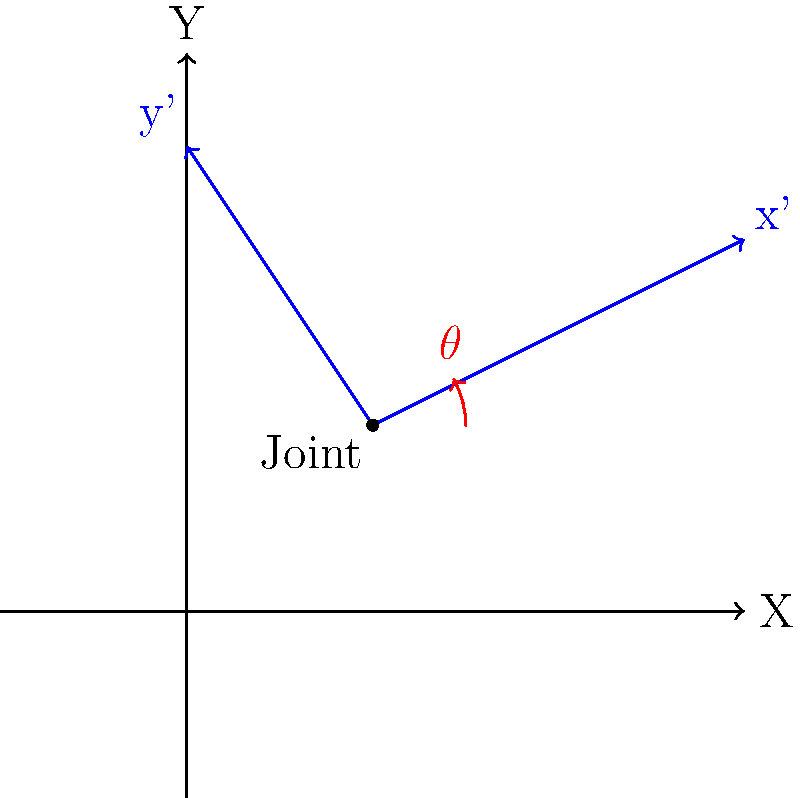In a biomechanical model of the human arm, a joint angle $\theta$ is measured as 30° in the local coordinate system (x', y'). The local coordinate system is rotated 45° counterclockwise relative to the global coordinate system (X, Y). What is the joint angle $\theta_{global}$ in the global coordinate system? To solve this problem, we need to follow these steps:

1) Understand the given information:
   - Local joint angle $\theta_{local} = 30°$
   - Local coordinate system is rotated 45° counterclockwise from the global system

2) Recall the formula for coordinate system transformation:
   $\theta_{global} = \theta_{local} + \theta_{rotation}$

   Where $\theta_{rotation}$ is the angle of rotation between the local and global coordinate systems.

3) In this case:
   $\theta_{rotation} = 45°$ (given in the problem)

4) Apply the formula:
   $\theta_{global} = \theta_{local} + \theta_{rotation}$
   $\theta_{global} = 30° + 45°$
   $\theta_{global} = 75°$

Therefore, the joint angle in the global coordinate system is 75°.
Answer: 75° 